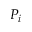<formula> <loc_0><loc_0><loc_500><loc_500>P _ { i }</formula> 